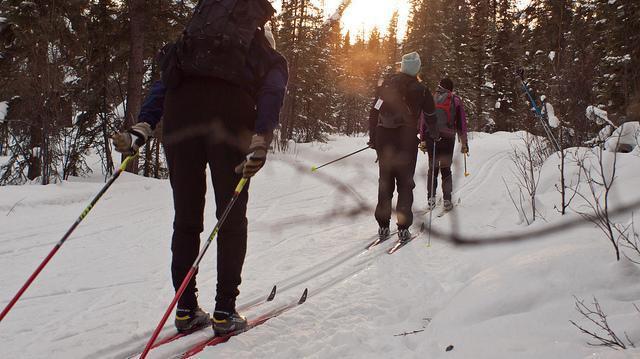How many people are skiing?
Give a very brief answer. 3. How many people are visible?
Give a very brief answer. 3. How many cakes are on the table?
Give a very brief answer. 0. 